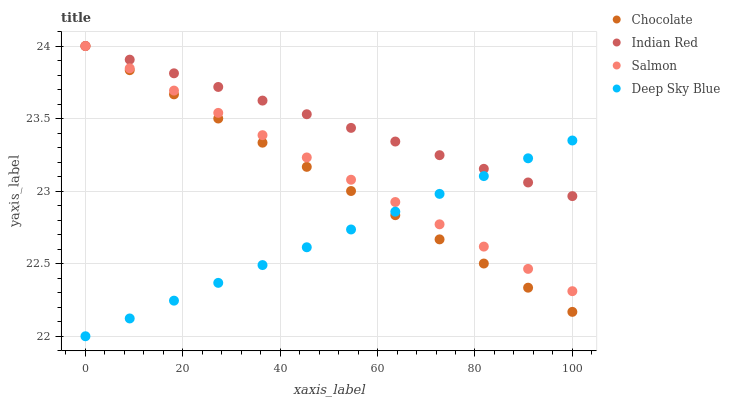Does Deep Sky Blue have the minimum area under the curve?
Answer yes or no. Yes. Does Indian Red have the maximum area under the curve?
Answer yes or no. Yes. Does Indian Red have the minimum area under the curve?
Answer yes or no. No. Does Deep Sky Blue have the maximum area under the curve?
Answer yes or no. No. Is Deep Sky Blue the smoothest?
Answer yes or no. Yes. Is Indian Red the roughest?
Answer yes or no. Yes. Is Indian Red the smoothest?
Answer yes or no. No. Is Deep Sky Blue the roughest?
Answer yes or no. No. Does Deep Sky Blue have the lowest value?
Answer yes or no. Yes. Does Indian Red have the lowest value?
Answer yes or no. No. Does Chocolate have the highest value?
Answer yes or no. Yes. Does Deep Sky Blue have the highest value?
Answer yes or no. No. Does Chocolate intersect Salmon?
Answer yes or no. Yes. Is Chocolate less than Salmon?
Answer yes or no. No. Is Chocolate greater than Salmon?
Answer yes or no. No. 